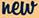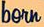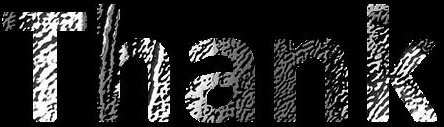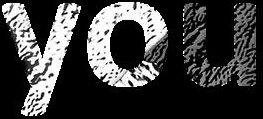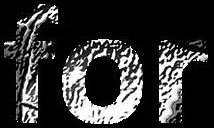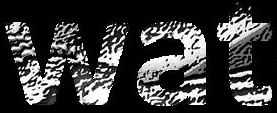What words are shown in these images in order, separated by a semicolon? new; born; Thank; you; for; wat 